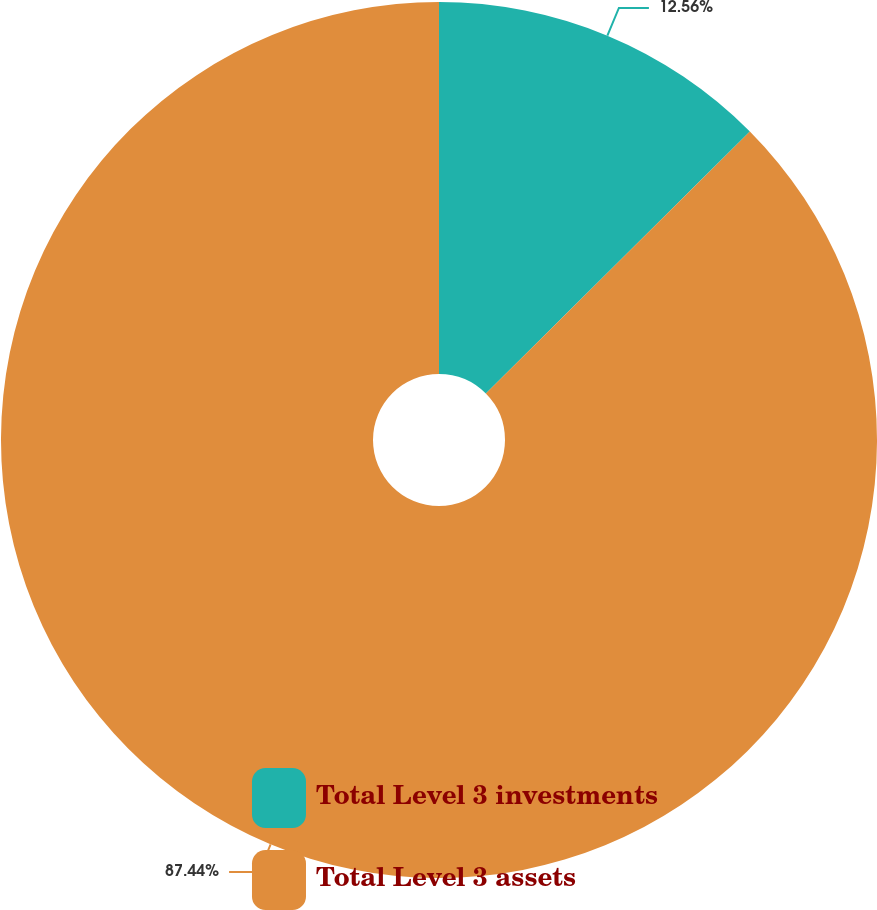Convert chart to OTSL. <chart><loc_0><loc_0><loc_500><loc_500><pie_chart><fcel>Total Level 3 investments<fcel>Total Level 3 assets<nl><fcel>12.56%<fcel>87.44%<nl></chart> 